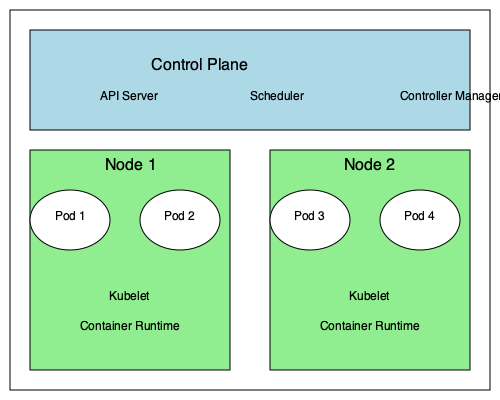In the given Kubernetes cluster diagram, what component is responsible for scheduling pods onto nodes and where is it located? To answer this question, let's break down the structure of the Kubernetes cluster shown in the diagram:

1. The cluster is divided into two main parts: the Control Plane and the Nodes.

2. The Control Plane, shown at the top of the diagram, contains three key components:
   a. API Server
   b. Scheduler
   c. Controller Manager

3. The Nodes, shown below the Control Plane, represent the worker machines where containers are deployed and run.

4. Each Node contains:
   a. Pods (which encapsulate containers)
   b. Kubelet (which communicates with the Control Plane)
   c. Container Runtime (which runs the containers)

5. The component responsible for scheduling pods onto nodes is the Scheduler.

6. The Scheduler is located in the Control Plane, as clearly shown in the diagram.

The Scheduler's main task is to watch for newly created pods that have no node assigned, and select the best node for them to run on. It takes into account factors such as resource requirements, hardware/software/policy constraints, affinity and anti-affinity specifications, and more.
Answer: The Scheduler, located in the Control Plane. 